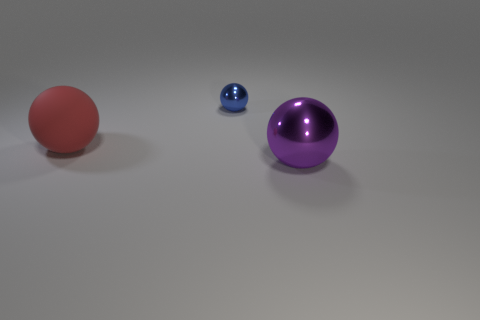Subtract all large matte spheres. How many spheres are left? 2 Add 3 cyan matte cylinders. How many objects exist? 6 Subtract all brown balls. Subtract all red cubes. How many balls are left? 3 Add 1 blue objects. How many blue objects are left? 2 Add 1 gray metal blocks. How many gray metal blocks exist? 1 Subtract 0 purple cylinders. How many objects are left? 3 Subtract all large cyan shiny things. Subtract all large rubber things. How many objects are left? 2 